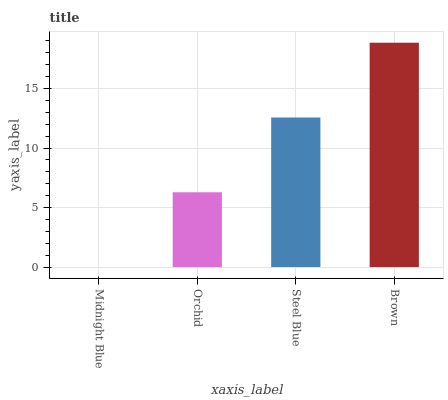Is Midnight Blue the minimum?
Answer yes or no. Yes. Is Brown the maximum?
Answer yes or no. Yes. Is Orchid the minimum?
Answer yes or no. No. Is Orchid the maximum?
Answer yes or no. No. Is Orchid greater than Midnight Blue?
Answer yes or no. Yes. Is Midnight Blue less than Orchid?
Answer yes or no. Yes. Is Midnight Blue greater than Orchid?
Answer yes or no. No. Is Orchid less than Midnight Blue?
Answer yes or no. No. Is Steel Blue the high median?
Answer yes or no. Yes. Is Orchid the low median?
Answer yes or no. Yes. Is Midnight Blue the high median?
Answer yes or no. No. Is Brown the low median?
Answer yes or no. No. 